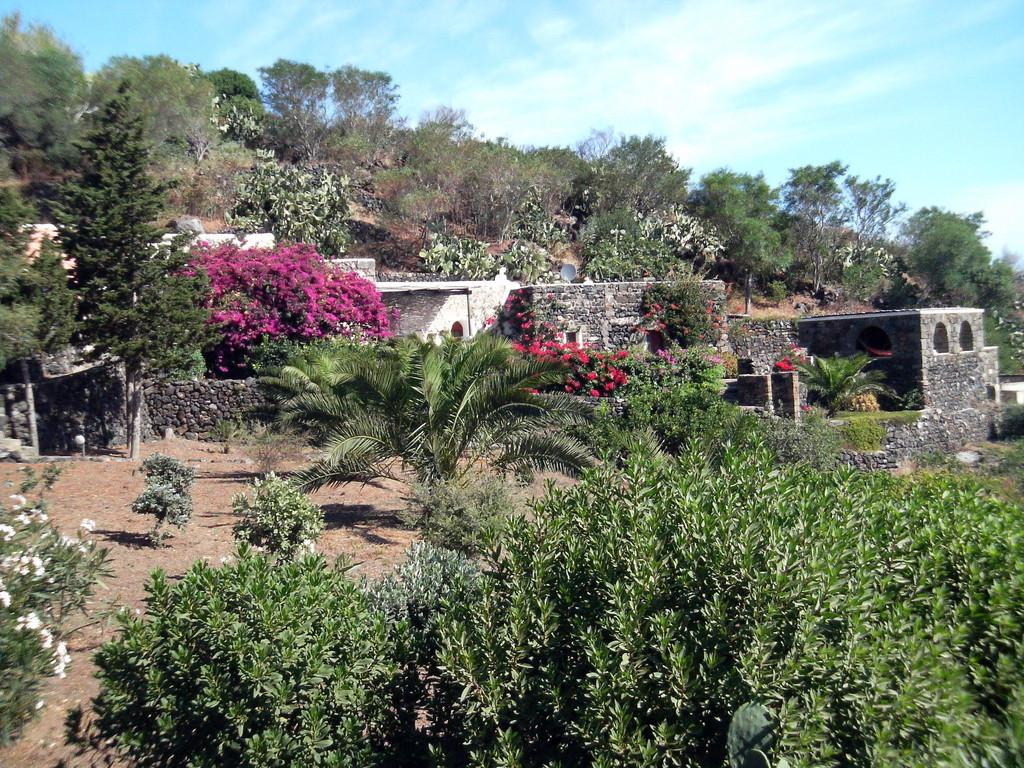What type of structure is present in the image? There is a building in the image. Where is the building located? The building is on the ground. What other natural elements can be seen in the image? There are trees and plants with flowers in the image. What is visible in the background of the image? The sky is visible in the image. What type of invention can be seen in the image? There is no invention present in the image; it features a building, trees, plants with flowers, and the sky. How many clovers are visible in the image? There are no clovers visible in the image; it features a building, trees, plants with flowers, and the sky. 